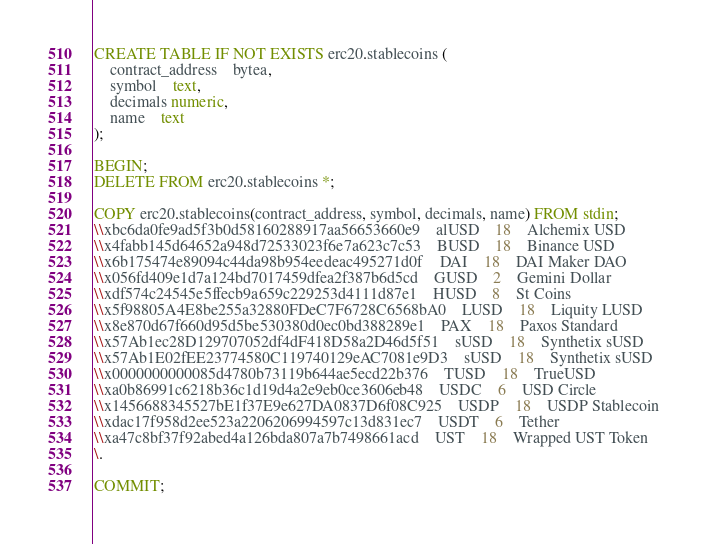<code> <loc_0><loc_0><loc_500><loc_500><_SQL_>CREATE TABLE IF NOT EXISTS erc20.stablecoins (
    contract_address	bytea,
    symbol	text,
    decimals numeric,
    name	text
);

BEGIN;
DELETE FROM erc20.stablecoins *;

COPY erc20.stablecoins(contract_address, symbol, decimals, name) FROM stdin;
\\xbc6da0fe9ad5f3b0d58160288917aa56653660e9	alUSD	18	Alchemix USD
\\x4fabb145d64652a948d72533023f6e7a623c7c53	BUSD	18	Binance USD
\\x6b175474e89094c44da98b954eedeac495271d0f	DAI	18	DAI Maker DAO
\\x056fd409e1d7a124bd7017459dfea2f387b6d5cd	GUSD	2	Gemini Dollar
\\xdf574c24545e5ffecb9a659c229253d4111d87e1	HUSD	8	St Coins
\\x5f98805A4E8be255a32880FDeC7F6728C6568bA0	LUSD	18	Liquity LUSD
\\x8e870d67f660d95d5be530380d0ec0bd388289e1	PAX	18	Paxos Standard
\\x57Ab1ec28D129707052df4dF418D58a2D46d5f51	sUSD	18	Synthetix sUSD
\\x57Ab1E02fEE23774580C119740129eAC7081e9D3	sUSD	18	Synthetix sUSD
\\x0000000000085d4780b73119b644ae5ecd22b376	TUSD	18	TrueUSD
\\xa0b86991c6218b36c1d19d4a2e9eb0ce3606eb48	USDC	6	USD Circle
\\x1456688345527bE1f37E9e627DA0837D6f08C925	USDP	18	USDP Stablecoin
\\xdac17f958d2ee523a2206206994597c13d831ec7	USDT	6	Tether
\\xa47c8bf37f92abed4a126bda807a7b7498661acd	UST	18	Wrapped UST Token
\.

COMMIT;
</code> 